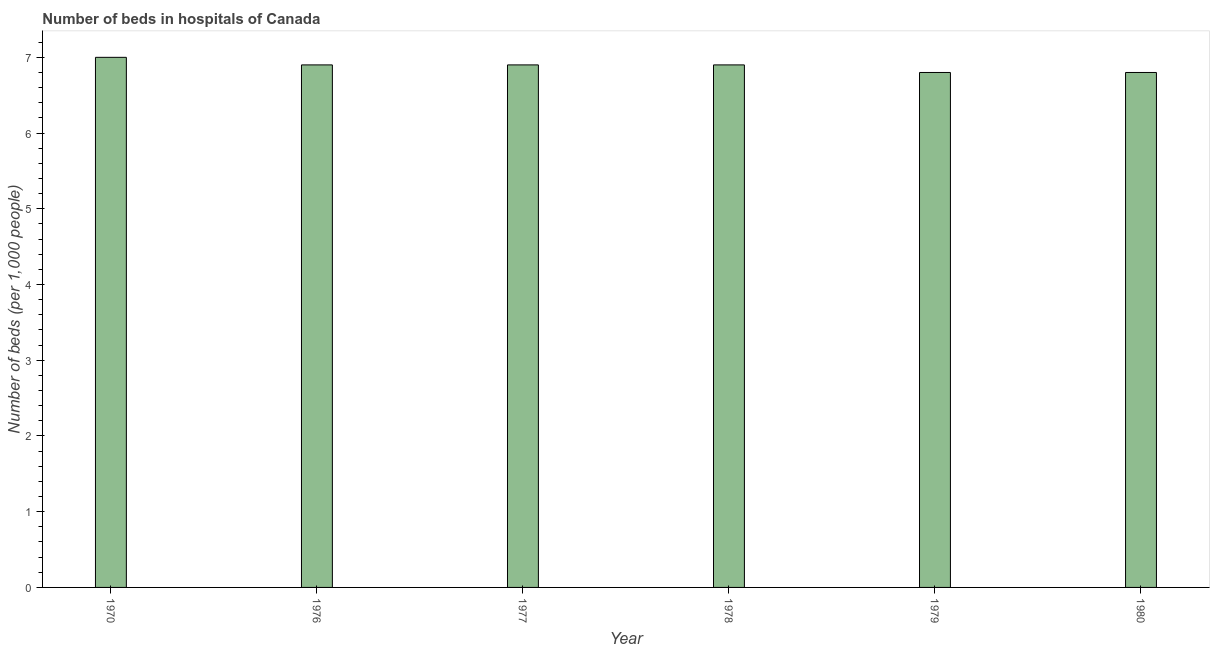What is the title of the graph?
Give a very brief answer. Number of beds in hospitals of Canada. What is the label or title of the Y-axis?
Keep it short and to the point. Number of beds (per 1,0 people). What is the number of hospital beds in 1976?
Your answer should be very brief. 6.9. Across all years, what is the maximum number of hospital beds?
Your answer should be compact. 7. Across all years, what is the minimum number of hospital beds?
Give a very brief answer. 6.8. In which year was the number of hospital beds minimum?
Offer a terse response. 1979. What is the sum of the number of hospital beds?
Give a very brief answer. 41.3. What is the difference between the number of hospital beds in 1977 and 1980?
Ensure brevity in your answer.  0.1. What is the average number of hospital beds per year?
Offer a very short reply. 6.88. What is the median number of hospital beds?
Offer a terse response. 6.9. In how many years, is the number of hospital beds greater than 3.8 %?
Offer a terse response. 6. What is the ratio of the number of hospital beds in 1970 to that in 1980?
Give a very brief answer. 1.03. Is the number of hospital beds in 1970 less than that in 1980?
Offer a terse response. No. Is the difference between the number of hospital beds in 1976 and 1978 greater than the difference between any two years?
Make the answer very short. No. What is the difference between the highest and the second highest number of hospital beds?
Your answer should be very brief. 0.1. Is the sum of the number of hospital beds in 1970 and 1978 greater than the maximum number of hospital beds across all years?
Offer a very short reply. Yes. In how many years, is the number of hospital beds greater than the average number of hospital beds taken over all years?
Provide a succinct answer. 4. How many bars are there?
Ensure brevity in your answer.  6. Are all the bars in the graph horizontal?
Keep it short and to the point. No. How many years are there in the graph?
Your response must be concise. 6. What is the difference between two consecutive major ticks on the Y-axis?
Offer a very short reply. 1. What is the Number of beds (per 1,000 people) of 1976?
Your response must be concise. 6.9. What is the Number of beds (per 1,000 people) of 1977?
Make the answer very short. 6.9. What is the Number of beds (per 1,000 people) in 1978?
Make the answer very short. 6.9. What is the Number of beds (per 1,000 people) of 1979?
Offer a terse response. 6.8. What is the Number of beds (per 1,000 people) in 1980?
Offer a terse response. 6.8. What is the difference between the Number of beds (per 1,000 people) in 1970 and 1979?
Your answer should be very brief. 0.2. What is the difference between the Number of beds (per 1,000 people) in 1970 and 1980?
Provide a short and direct response. 0.2. What is the difference between the Number of beds (per 1,000 people) in 1976 and 1979?
Give a very brief answer. 0.1. What is the difference between the Number of beds (per 1,000 people) in 1977 and 1980?
Your answer should be very brief. 0.1. What is the difference between the Number of beds (per 1,000 people) in 1979 and 1980?
Your response must be concise. 0. What is the ratio of the Number of beds (per 1,000 people) in 1970 to that in 1976?
Ensure brevity in your answer.  1.01. What is the ratio of the Number of beds (per 1,000 people) in 1970 to that in 1979?
Offer a very short reply. 1.03. What is the ratio of the Number of beds (per 1,000 people) in 1976 to that in 1977?
Ensure brevity in your answer.  1. What is the ratio of the Number of beds (per 1,000 people) in 1977 to that in 1978?
Keep it short and to the point. 1. What is the ratio of the Number of beds (per 1,000 people) in 1979 to that in 1980?
Offer a terse response. 1. 